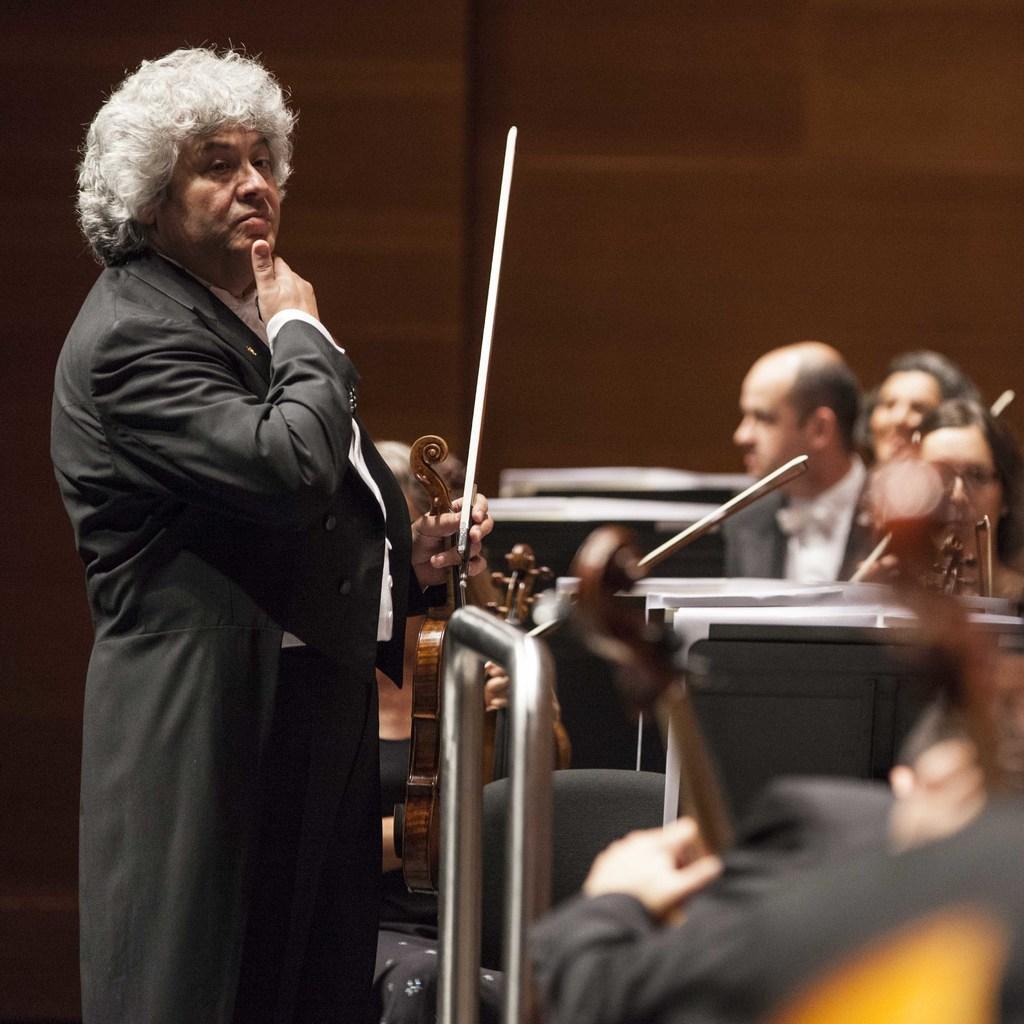Could you give a brief overview of what you see in this image? On the left side, we see a man is standing and he is holding a stick in his hand. In front of him, we see the people are sitting on the chairs and they are holding the musical instruments in their hands. In front of them, we see the tables. At the bottom, we see an iron rod. In the background, we see a wall, which is brown in color. This picture is blurred in the background. 